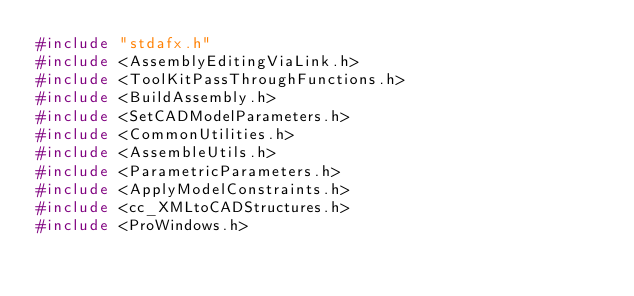Convert code to text. <code><loc_0><loc_0><loc_500><loc_500><_C++_>#include "stdafx.h"
#include <AssemblyEditingViaLink.h>
#include <ToolKitPassThroughFunctions.h>
#include <BuildAssembly.h>
#include <SetCADModelParameters.h>
#include <CommonUtilities.h>
#include <AssembleUtils.h>
#include <ParametricParameters.h>
#include <ApplyModelConstraints.h>
#include <cc_XMLtoCADStructures.h>
#include <ProWindows.h></code> 